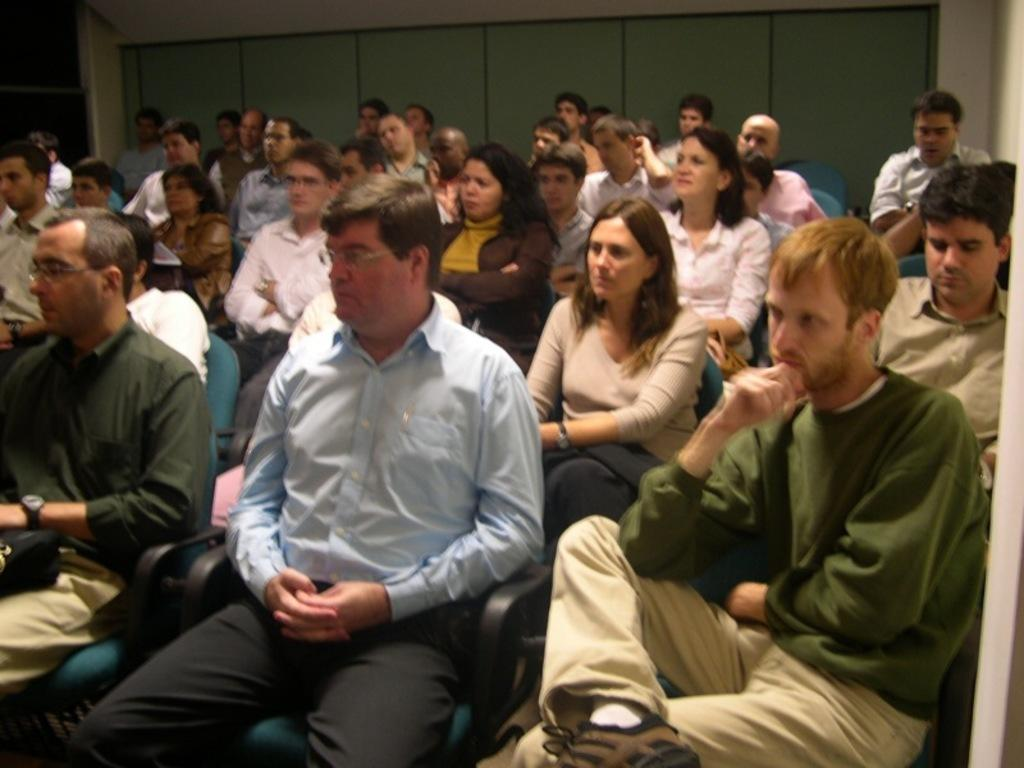What are the people in the image doing? The people in the image are sitting in chairs. How are the chairs arranged in the image? The chairs are arranged in rows. Are the chairs close to each other in the image? Yes, the chairs are beside each other in the image. What can be seen in the background of the image? There is a wall in the background of the image. What advice is the goat giving to the people sitting in the chairs in the image? There is no goat present in the image, so it cannot provide any advice. 